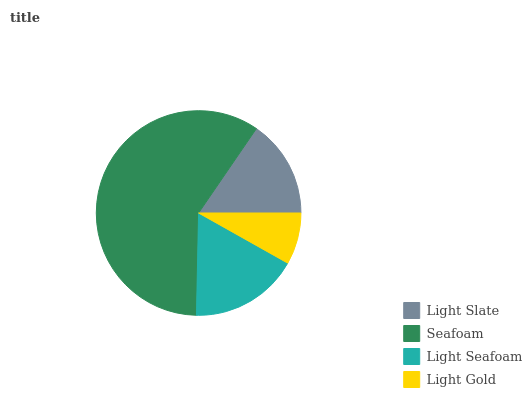Is Light Gold the minimum?
Answer yes or no. Yes. Is Seafoam the maximum?
Answer yes or no. Yes. Is Light Seafoam the minimum?
Answer yes or no. No. Is Light Seafoam the maximum?
Answer yes or no. No. Is Seafoam greater than Light Seafoam?
Answer yes or no. Yes. Is Light Seafoam less than Seafoam?
Answer yes or no. Yes. Is Light Seafoam greater than Seafoam?
Answer yes or no. No. Is Seafoam less than Light Seafoam?
Answer yes or no. No. Is Light Seafoam the high median?
Answer yes or no. Yes. Is Light Slate the low median?
Answer yes or no. Yes. Is Light Slate the high median?
Answer yes or no. No. Is Seafoam the low median?
Answer yes or no. No. 